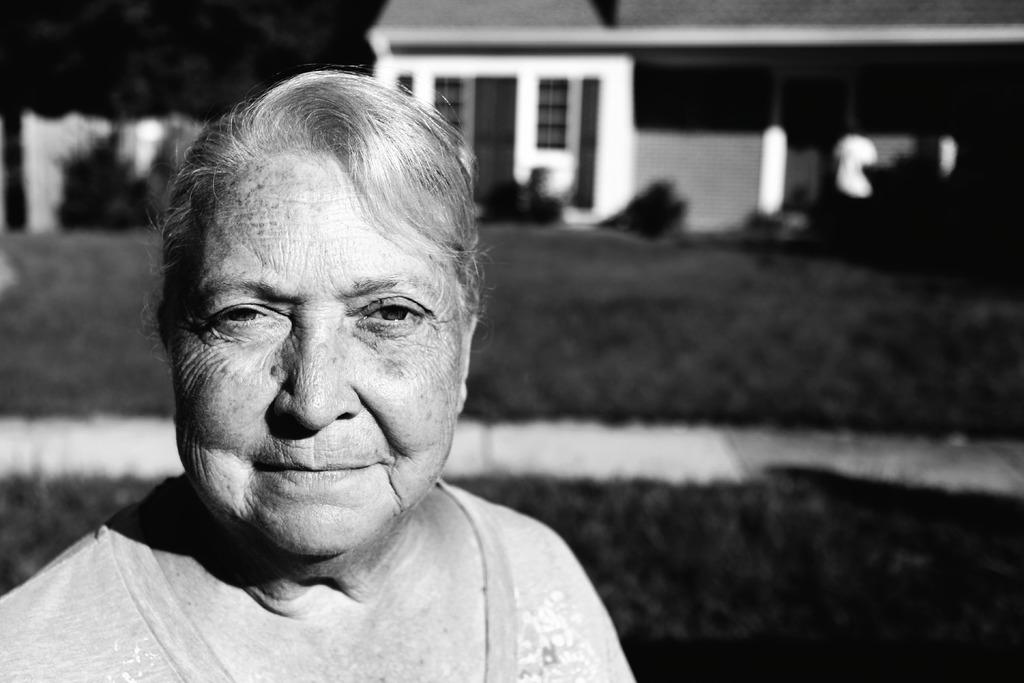Who is present in the image? There is a woman in the image. What is the woman's facial expression? The woman is smiling. What can be seen in the background of the image? There is a house and trees in the background of the image. What type of goat can be seen in the image? There is no goat present in the image. How does the acoustics of the woman's voice change in the image? There is no information about the woman's voice or the acoustics in the image. 